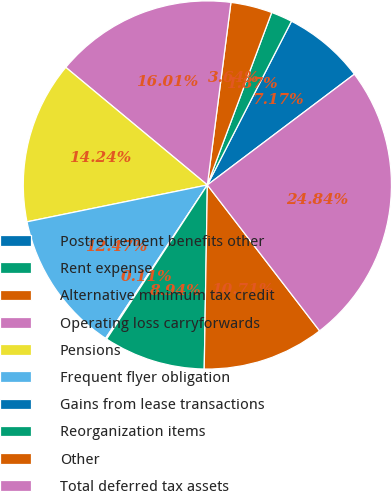<chart> <loc_0><loc_0><loc_500><loc_500><pie_chart><fcel>Postretirement benefits other<fcel>Rent expense<fcel>Alternative minimum tax credit<fcel>Operating loss carryforwards<fcel>Pensions<fcel>Frequent flyer obligation<fcel>Gains from lease transactions<fcel>Reorganization items<fcel>Other<fcel>Total deferred tax assets<nl><fcel>7.17%<fcel>1.87%<fcel>3.64%<fcel>16.01%<fcel>14.24%<fcel>12.47%<fcel>0.11%<fcel>8.94%<fcel>10.71%<fcel>24.84%<nl></chart> 